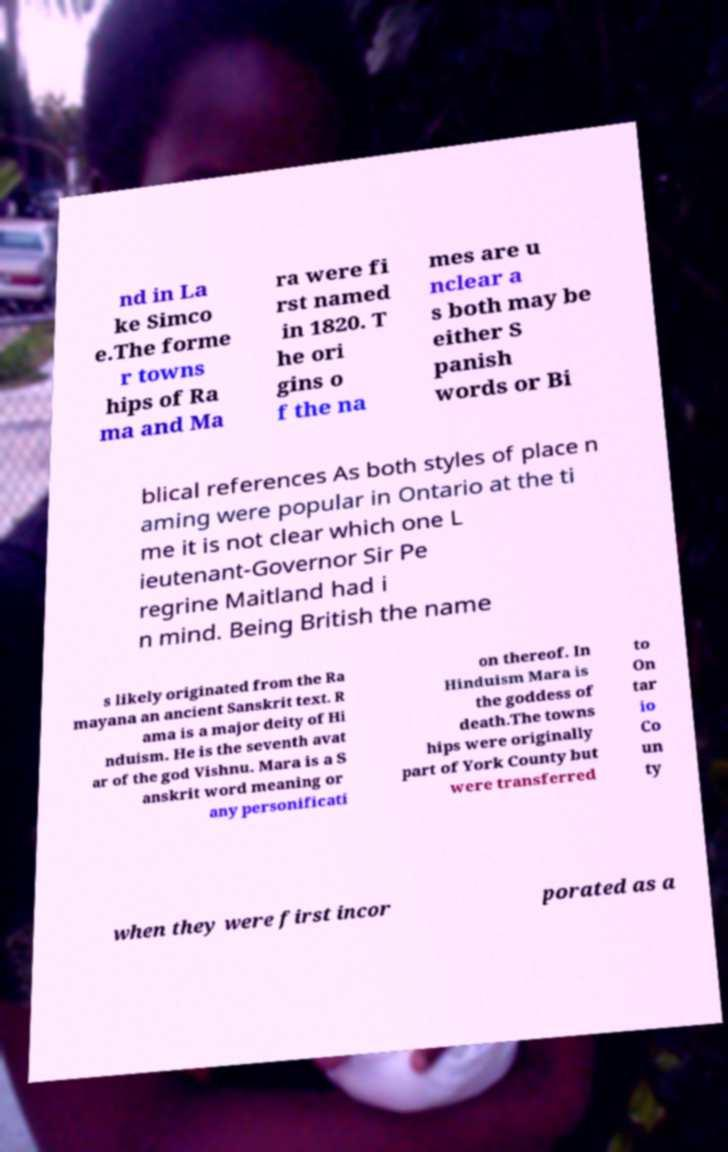Please read and relay the text visible in this image. What does it say? nd in La ke Simco e.The forme r towns hips of Ra ma and Ma ra were fi rst named in 1820. T he ori gins o f the na mes are u nclear a s both may be either S panish words or Bi blical references As both styles of place n aming were popular in Ontario at the ti me it is not clear which one L ieutenant-Governor Sir Pe regrine Maitland had i n mind. Being British the name s likely originated from the Ra mayana an ancient Sanskrit text. R ama is a major deity of Hi nduism. He is the seventh avat ar of the god Vishnu. Mara is a S anskrit word meaning or any personificati on thereof. In Hinduism Mara is the goddess of death.The towns hips were originally part of York County but were transferred to On tar io Co un ty when they were first incor porated as a 